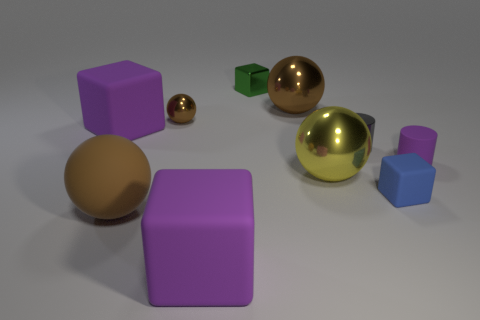Subtract all yellow cubes. How many brown balls are left? 3 Subtract all spheres. How many objects are left? 6 Subtract 0 red cylinders. How many objects are left? 10 Subtract all brown shiny things. Subtract all brown matte objects. How many objects are left? 7 Add 9 gray metallic things. How many gray metallic things are left? 10 Add 1 large red shiny objects. How many large red shiny objects exist? 1 